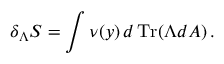<formula> <loc_0><loc_0><loc_500><loc_500>\delta _ { \Lambda } S = \int \nu ( y ) \, d \, T r ( \Lambda d A ) \, .</formula> 